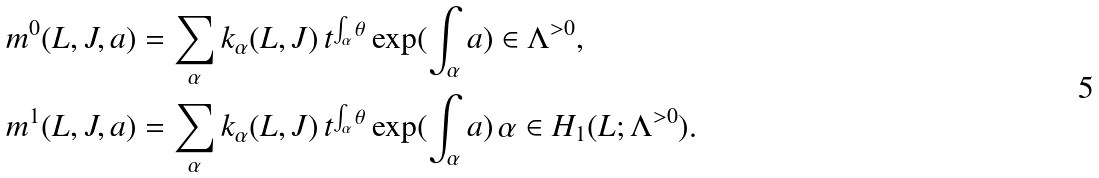<formula> <loc_0><loc_0><loc_500><loc_500>& m ^ { 0 } ( L , J , a ) = \sum _ { \alpha } k _ { \alpha } ( L , J ) \, t ^ { \int _ { \alpha } \theta } \exp ( \int _ { \alpha } a ) \in \Lambda ^ { > 0 } , \\ & m ^ { 1 } ( L , J , a ) = \sum _ { \alpha } k _ { \alpha } ( L , J ) \, t ^ { \int _ { \alpha } \theta } \exp ( \int _ { \alpha } a ) \, \alpha \in H _ { 1 } ( L ; \Lambda ^ { > 0 } ) .</formula> 